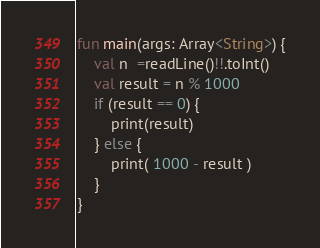Convert code to text. <code><loc_0><loc_0><loc_500><loc_500><_Kotlin_>fun main(args: Array<String>) {
    val n  =readLine()!!.toInt()
    val result = n % 1000
    if (result == 0) {
        print(result)
    } else {
        print( 1000 - result )
    }
}</code> 